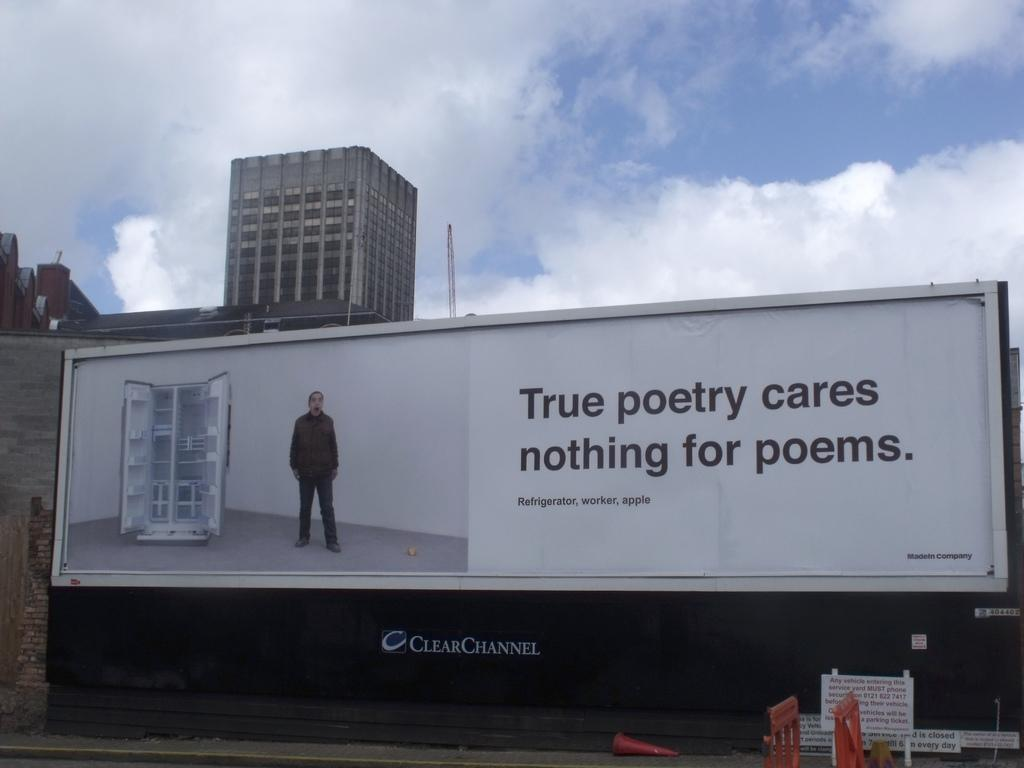<image>
Write a terse but informative summary of the picture. A billboard shows a man next to the phrase true poetry cares nothing for poems. 